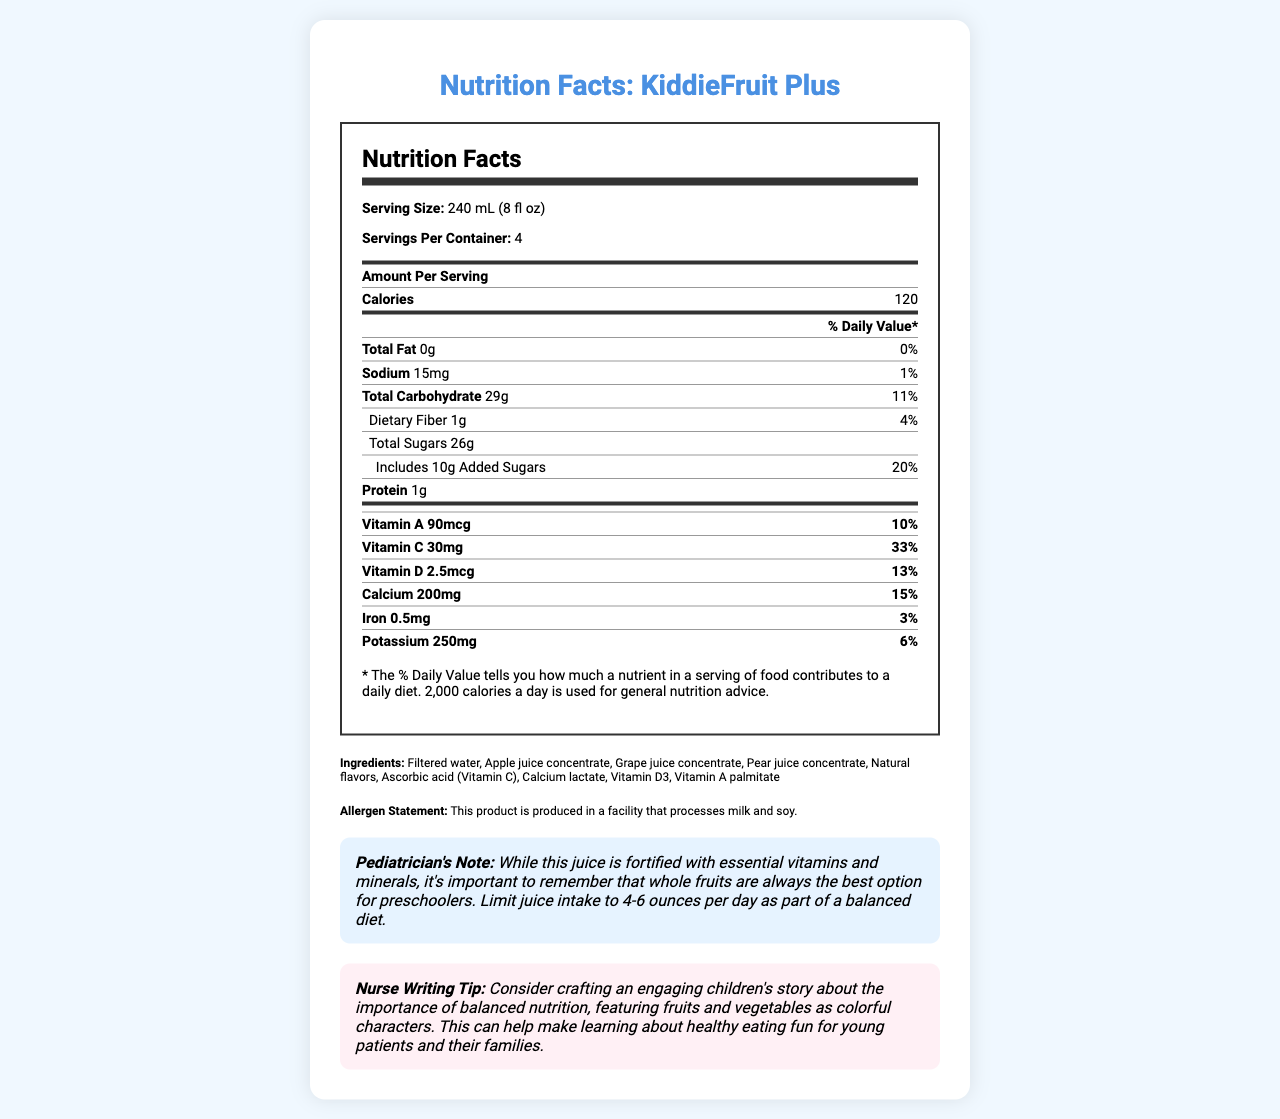what is the serving size of KiddieFruit Plus? The serving size is stated in the document as 240 mL (8 fl oz).
Answer: 240 mL (8 fl oz) how many servings are there in one container of KiddieFruit Plus? The document specifies that there are 4 servings per container.
Answer: 4 what is the amount of calcium in one serving of KiddieFruit Plus? According to the nutritional information, one serving contains 200mg of calcium.
Answer: 200mg what percentage of the daily value of Vitamin C does one serving provide? The document states that a serving provides 33% of the daily value for Vitamin C.
Answer: 33% how many grams of added sugars are in one serving? The nutritional label lists 10g of added sugars per serving.
Answer: 10g What is the main ingredient in KiddieFruit Plus? The first and main ingredient listed is filtered water.
Answer: Filtered water how many calories are there in one serving of KiddieFruit Plus? The document specifies that each serving contains 120 calories.
Answer: 120 which vitamin has the lowest daily value percentage in one serving? A. Vitamin A B. Vitamin C C. Vitamin D D. Iron The daily value percentage for iron is 3%, which is the lowest among the listed vitamins and minerals.
Answer: D. Iron Which statement is true about the protein content of KiddieFruit Plus? A. It contains no protein. B. It contains 1g of protein. C. It provides 10% of the daily value. According to the nutrition facts, KiddieFruit Plus contains 1g of protein.
Answer: B. It contains 1g of protein. Does the product have any fiber content? It has 1g of dietary fiber, which is 4% of the daily value.
Answer: Yes summarize the main idea of this document. The document outlines the nutrition facts, ingredients, and special notes for KiddieFruit Plus, emphasizing it as a fortified fruit juice for preschoolers with a balanced intake recommendation.
Answer: The document provides detailed nutritional information about KiddieFruit Plus, including serving size, calories, vitamins, minerals, ingredients, allergen statements, and notes for pediatricians and writing tips for nurses. why is KiddieFruit Plus suggested to be limited to 4-6 ounces per day for preschoolers? According to the pediatrician’s note, whole fruits are recommended over juice, which should be limited to moderate amounts for a balanced diet.
Answer: It is important to limit juice intake because whole fruits are preferred for better nutrition for preschoolers. what is the source of natural sweetness in KiddieFruit Plus? The ingredients section lists apple, grape, and pear juice concentrates, which provide natural sweetness.
Answer: Apple juice, Grape juice, and Pear juice concentrates What is the main caution provided in the allergen statement? The allergen statement warns that the product is made in a facility that handles milk and soy, which is crucial for individuals with allergies.
Answer: The product is produced in a facility that processes milk and soy. Which vitamin in KiddieFruit Plus helps in maintaining bone health? Vitamin D is known for its role in bone health, and the document lists it as one of the vitamins present.
Answer: Vitamin D How many vitamins and minerals are explicitly listed in the document? The document lists seven vitamins and minerals (Vitamin A, Vitamin C, Vitamin D, Calcium, Iron, Sodium, and Potassium).
Answer: Seven Who is the intended market for KiddieFruit Plus? The document indicates that the product is marketed towards preschoolers.
Answer: Preschoolers can KiddieFruit Plus be considered a high-protein drink? The protein content is only 1g per serving, which is relatively low.
Answer: No What is the primary theme suggested for a children's story to promote balanced nutrition? The nurse writing tip suggests crafting a story featuring fruits and vegetables as colorful characters.
Answer: Featuring fruits and vegetables as colorful characters Is KiddieFruit Plus a suitable substitute for whole fruits? The pediatrician's note recommends whole fruits as always the best option for preschoolers.
Answer: No what is the total amount of sugars in one serving, including added sugars? The total amount of sugars is listed as 26g per serving, including the 10g of added sugars.
Answer: 26g how can you describe the overall design and style of the document? The document is designed to be easily readable and engaging, with organized sections and clear typography.
Answer: The document is visually appealing with a clean, modern design. It uses a combination of bold headings, structured tables, and highlighted segments to clearly present the nutritional information and additional notes. Who consumes KiddieFruit Plus the most throughout the year? The document does not provide consumption data or demographic trends specific to the product.
Answer: Not enough information 